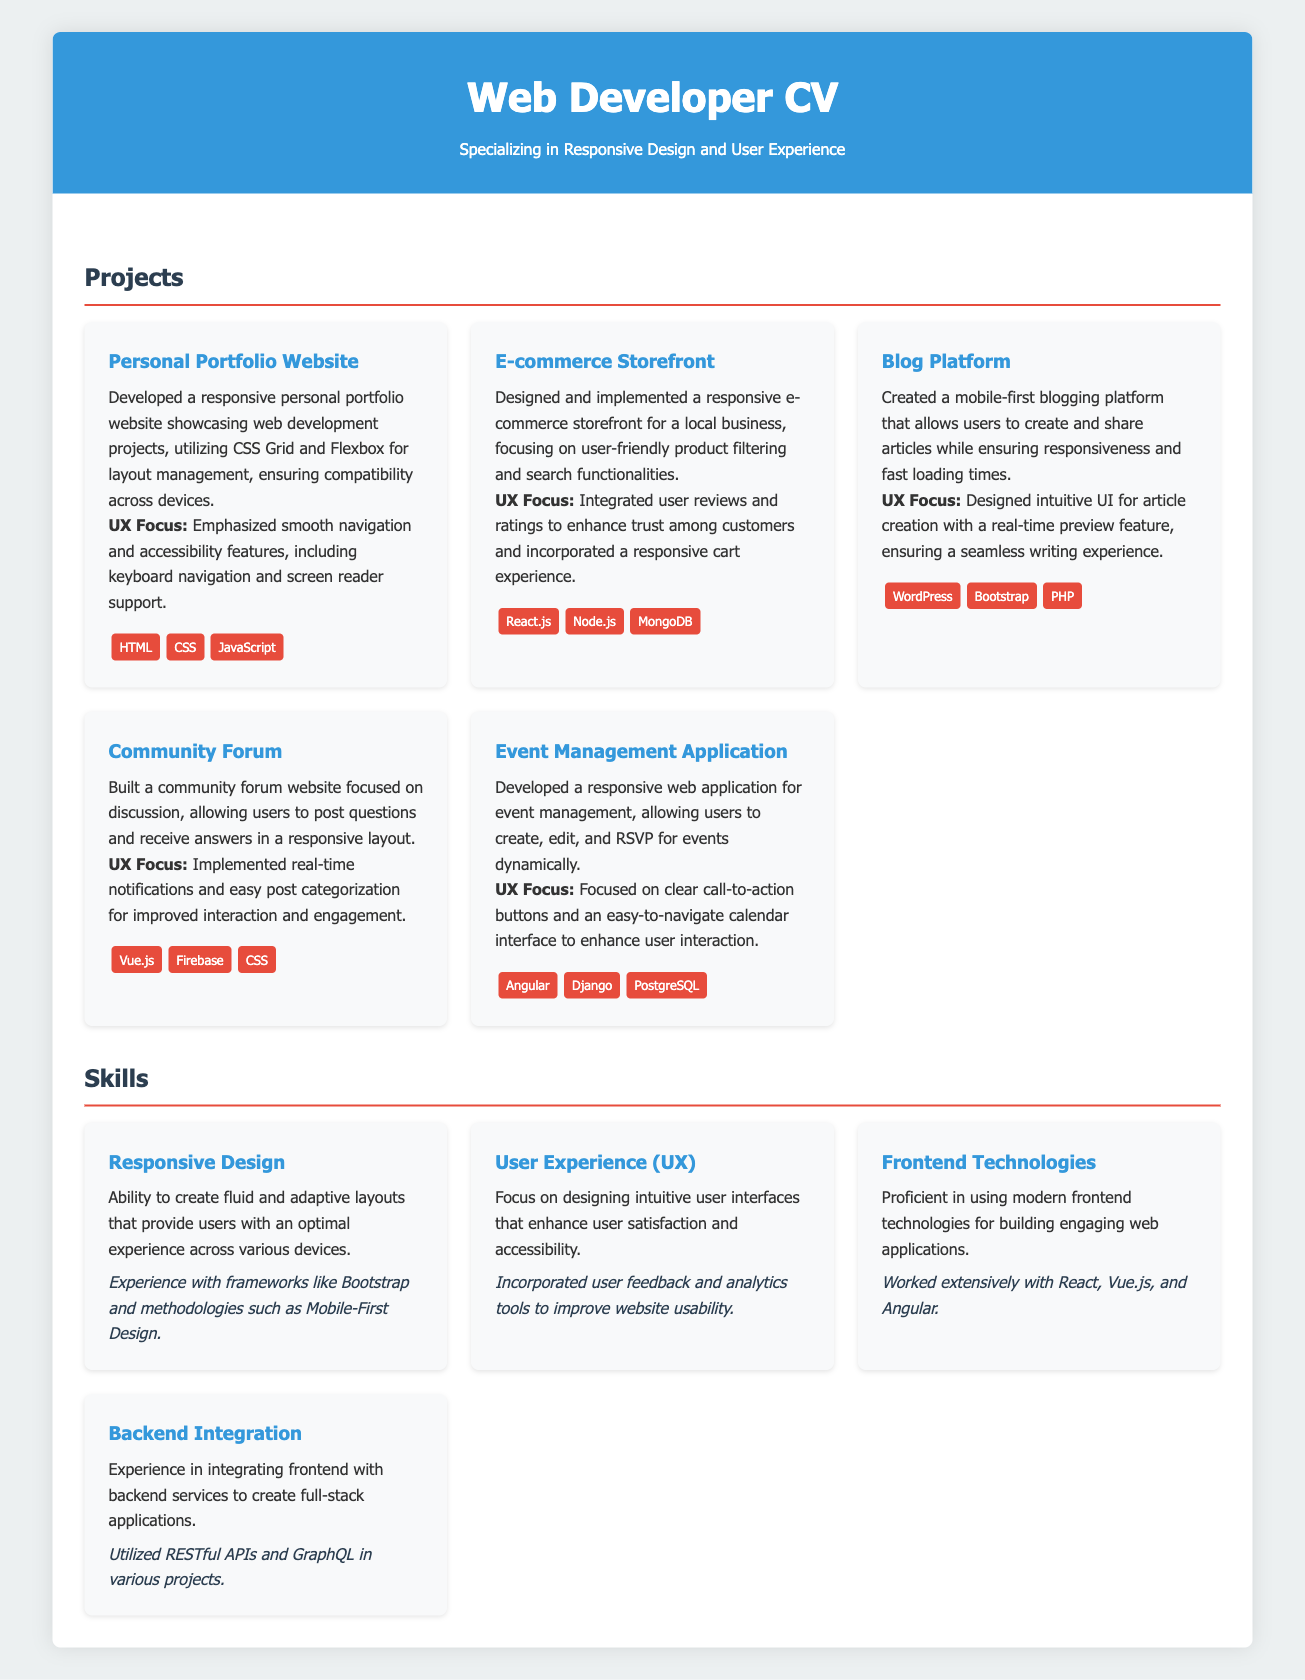What is the title of the CV? The title of the CV is clearly stated at the top of the document as "Web Developer CV - Responsive Design & UX Specialist."
Answer: Web Developer CV - Responsive Design & UX Specialist How many projects are listed in the Projects section? The document lists a total of five projects in the Projects section, each with their own description.
Answer: 5 Which project focuses on blogging? The project that focuses on blogging is described as a "mobile-first blogging platform."
Answer: Blog Platform What technology is used in the E-commerce Storefront project? The E-commerce Storefront project utilizes React.js, Node.js, and MongoDB as its technologies.
Answer: React.js, Node.js, MongoDB What is a UX focus mentioned for the Community Forum project? The Community Forum project mentions the implementation of real-time notifications and easy post categorization.
Answer: Real-time notifications and easy post categorization What skill is emphasized in the Skills section related to layouts? The skill related to creating layouts that provide an optimal experience is emphasized as "Responsive Design."
Answer: Responsive Design What is the assessment associated with User Experience skill? The assessment associated with the User Experience skill states, "Incorporated user feedback and analytics tools to improve website usability."
Answer: Incorporated user feedback and analytics tools to improve website usability In which project did the user focus on event management? The project focused on event management is titled "Event Management Application."
Answer: Event Management Application 